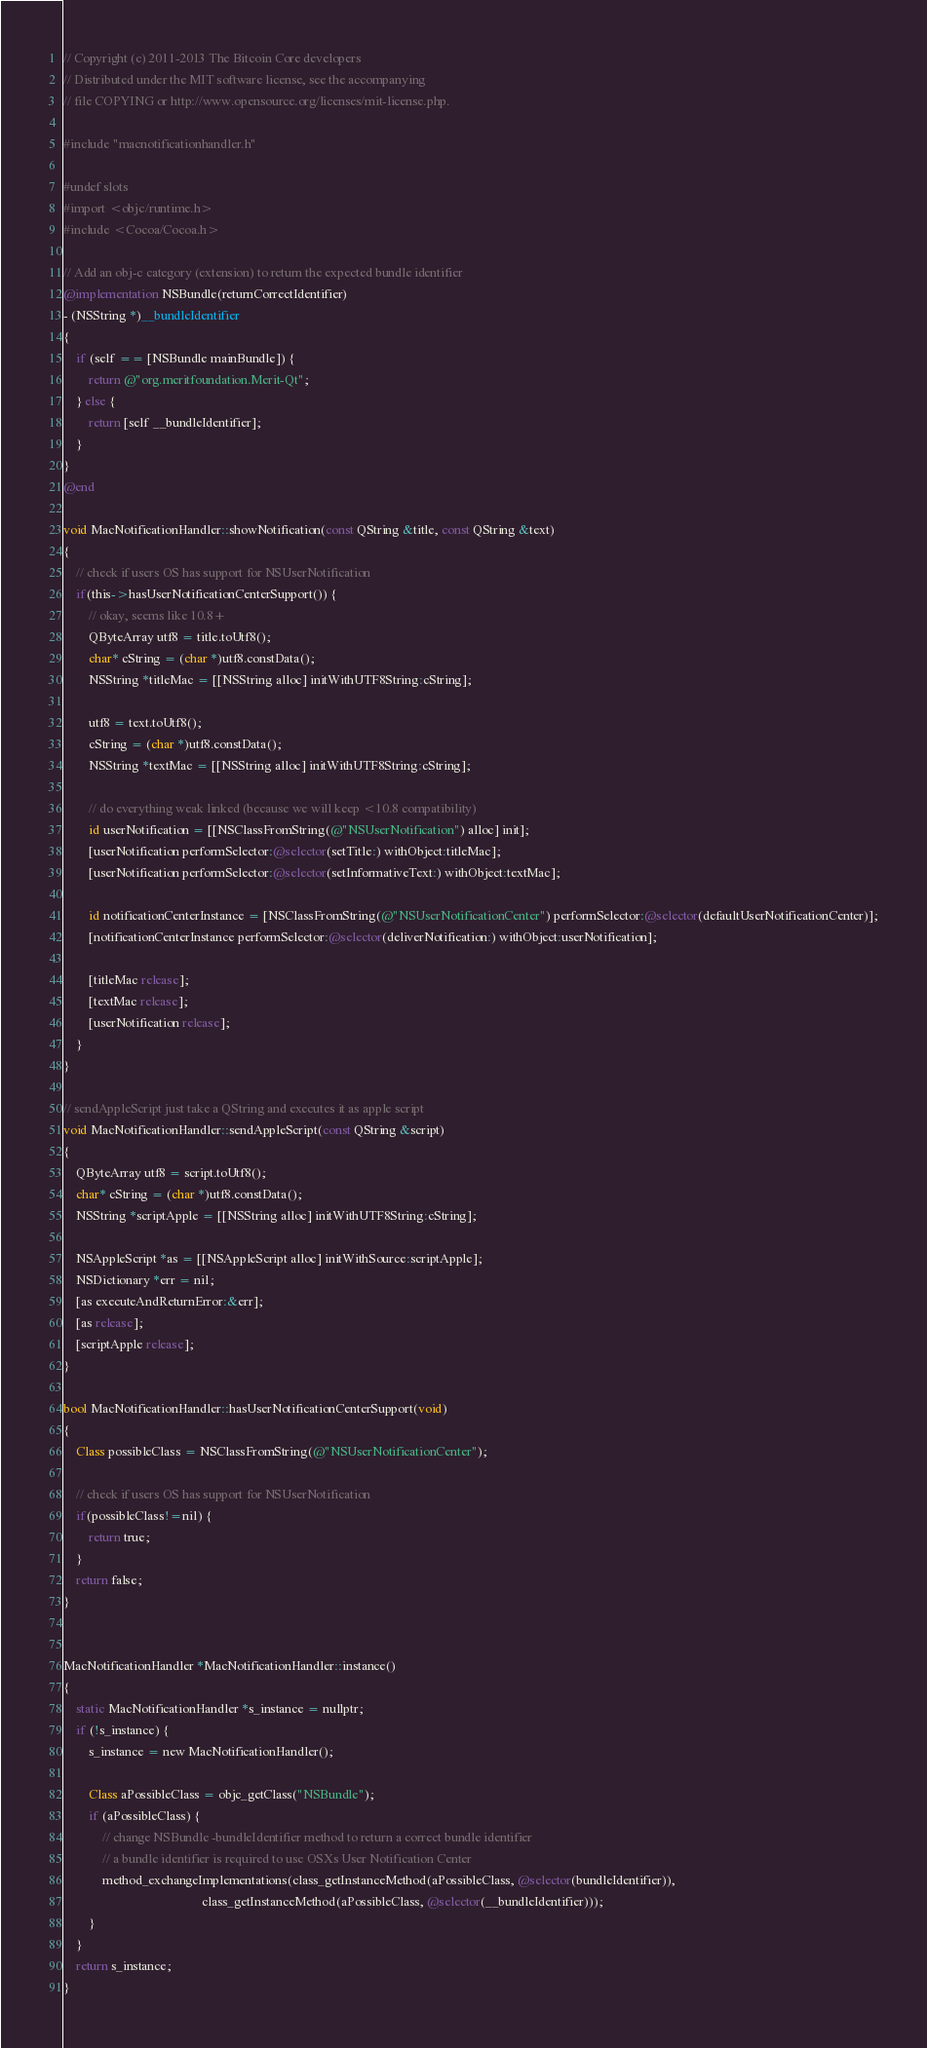<code> <loc_0><loc_0><loc_500><loc_500><_ObjectiveC_>// Copyright (c) 2011-2013 The Bitcoin Core developers
// Distributed under the MIT software license, see the accompanying
// file COPYING or http://www.opensource.org/licenses/mit-license.php.

#include "macnotificationhandler.h"

#undef slots
#import <objc/runtime.h>
#include <Cocoa/Cocoa.h>

// Add an obj-c category (extension) to return the expected bundle identifier
@implementation NSBundle(returnCorrectIdentifier)
- (NSString *)__bundleIdentifier
{
    if (self == [NSBundle mainBundle]) {
        return @"org.meritfoundation.Merit-Qt";
    } else {
        return [self __bundleIdentifier];
    }
}
@end

void MacNotificationHandler::showNotification(const QString &title, const QString &text)
{
    // check if users OS has support for NSUserNotification
    if(this->hasUserNotificationCenterSupport()) {
        // okay, seems like 10.8+
        QByteArray utf8 = title.toUtf8();
        char* cString = (char *)utf8.constData();
        NSString *titleMac = [[NSString alloc] initWithUTF8String:cString];

        utf8 = text.toUtf8();
        cString = (char *)utf8.constData();
        NSString *textMac = [[NSString alloc] initWithUTF8String:cString];

        // do everything weak linked (because we will keep <10.8 compatibility)
        id userNotification = [[NSClassFromString(@"NSUserNotification") alloc] init];
        [userNotification performSelector:@selector(setTitle:) withObject:titleMac];
        [userNotification performSelector:@selector(setInformativeText:) withObject:textMac];

        id notificationCenterInstance = [NSClassFromString(@"NSUserNotificationCenter") performSelector:@selector(defaultUserNotificationCenter)];
        [notificationCenterInstance performSelector:@selector(deliverNotification:) withObject:userNotification];

        [titleMac release];
        [textMac release];
        [userNotification release];
    }
}

// sendAppleScript just take a QString and executes it as apple script
void MacNotificationHandler::sendAppleScript(const QString &script)
{
    QByteArray utf8 = script.toUtf8();
    char* cString = (char *)utf8.constData();
    NSString *scriptApple = [[NSString alloc] initWithUTF8String:cString];

    NSAppleScript *as = [[NSAppleScript alloc] initWithSource:scriptApple];
    NSDictionary *err = nil;
    [as executeAndReturnError:&err];
    [as release];
    [scriptApple release];
}

bool MacNotificationHandler::hasUserNotificationCenterSupport(void)
{
    Class possibleClass = NSClassFromString(@"NSUserNotificationCenter");

    // check if users OS has support for NSUserNotification
    if(possibleClass!=nil) {
        return true;
    }
    return false;
}


MacNotificationHandler *MacNotificationHandler::instance()
{
    static MacNotificationHandler *s_instance = nullptr;
    if (!s_instance) {
        s_instance = new MacNotificationHandler();

        Class aPossibleClass = objc_getClass("NSBundle");
        if (aPossibleClass) {
            // change NSBundle -bundleIdentifier method to return a correct bundle identifier
            // a bundle identifier is required to use OSXs User Notification Center
            method_exchangeImplementations(class_getInstanceMethod(aPossibleClass, @selector(bundleIdentifier)),
                                           class_getInstanceMethod(aPossibleClass, @selector(__bundleIdentifier)));
        }
    }
    return s_instance;
}
</code> 